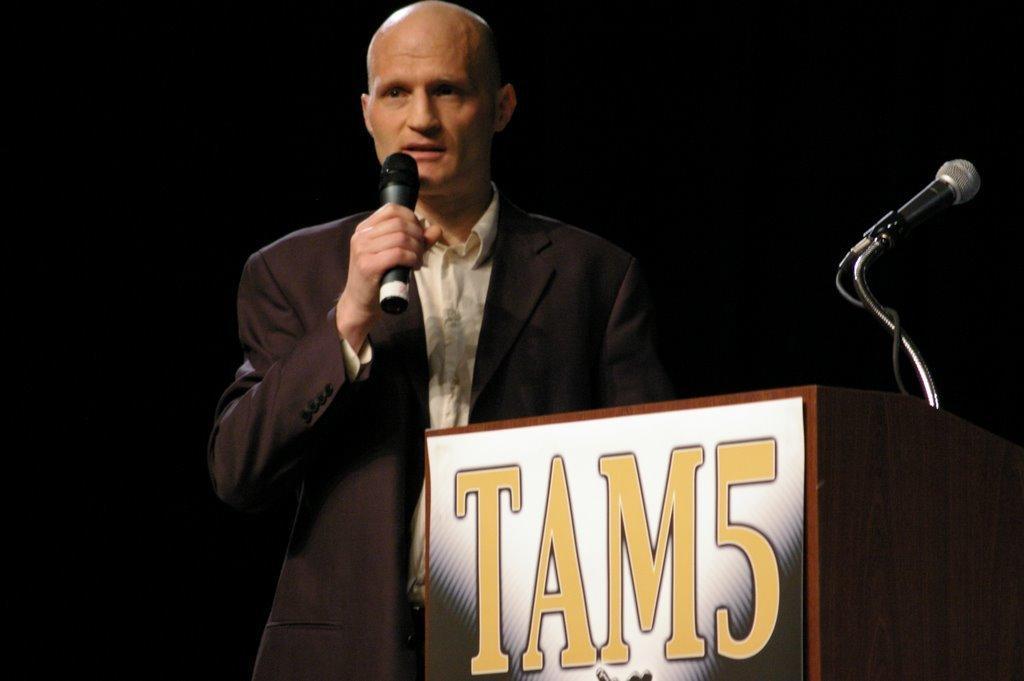Can you describe this image briefly? Here a man is standing and holding microphone in his hand. On the right there is a podium and microphone. 